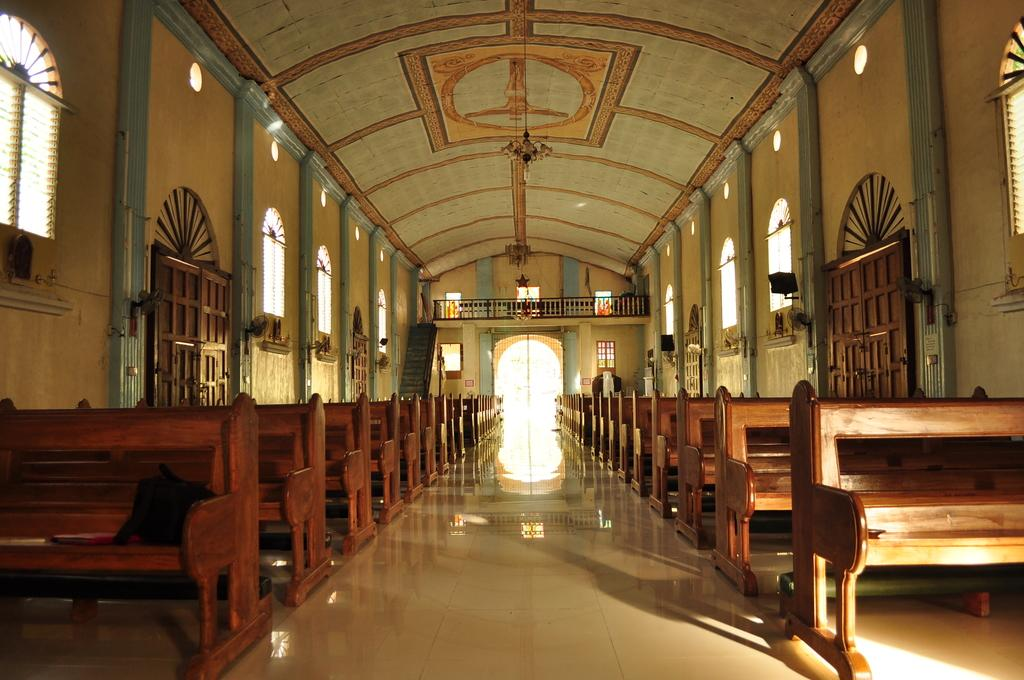What type of building is shown in the image? The image appears to depict a church. What type of seating is available in the image? There are benches in the image, which are for sitting. What are the two main features of the church that allow for light and ventilation? There are doors and windows in the image. Where is the quicksand located in the image? There is no quicksand present in the image. What type of button can be seen on the church doors in the image? There are no buttons visible on the church doors in the image. 